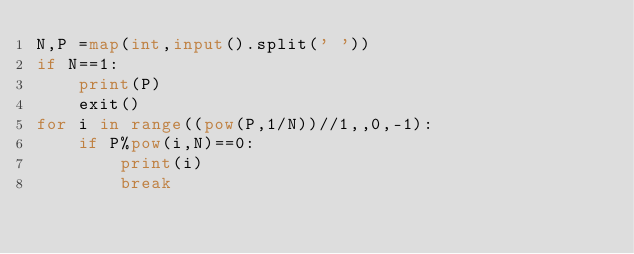<code> <loc_0><loc_0><loc_500><loc_500><_Python_>N,P =map(int,input().split(' '))
if N==1:
    print(P)
    exit()
for i in range((pow(P,1/N))//1,,0,-1):
    if P%pow(i,N)==0:
        print(i)
        break</code> 